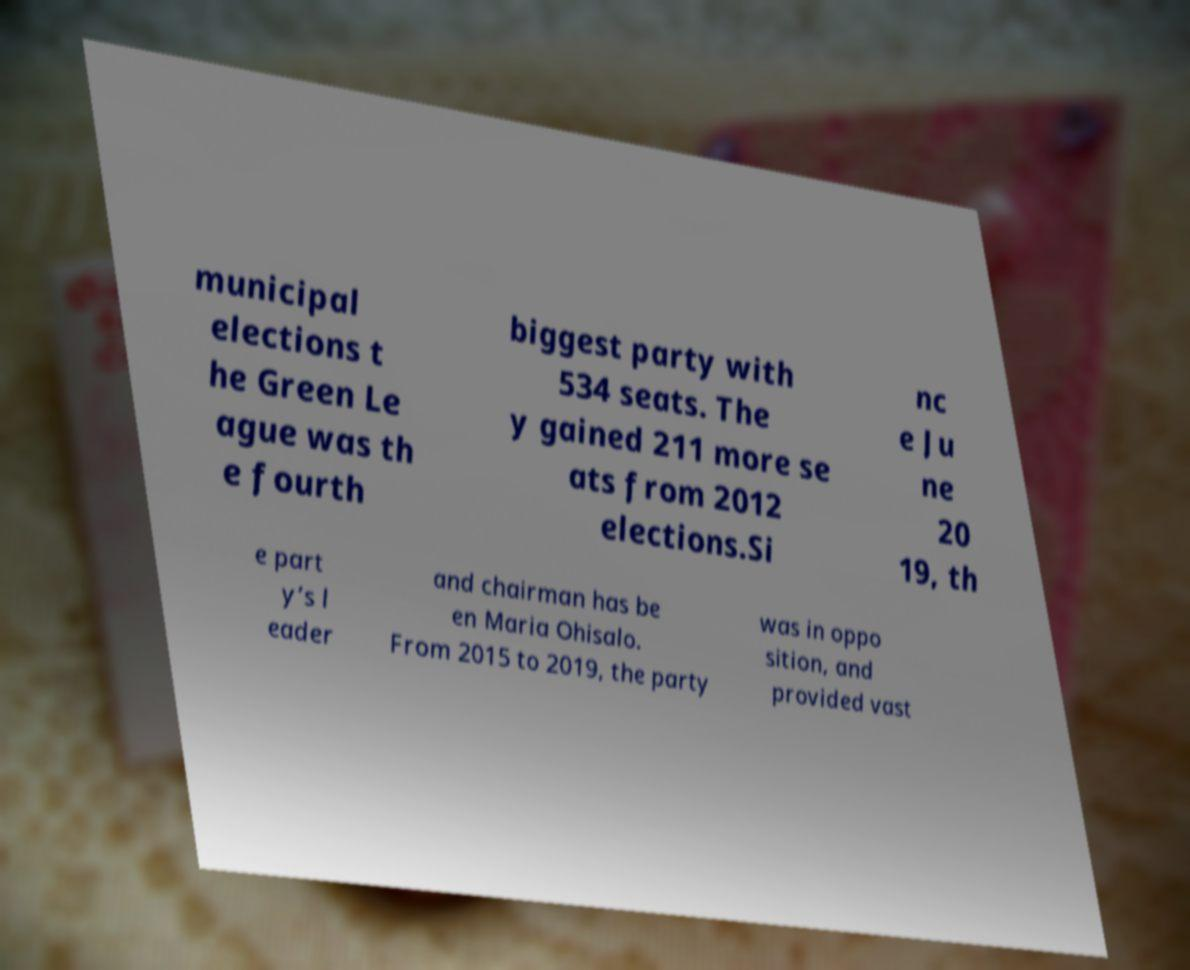What messages or text are displayed in this image? I need them in a readable, typed format. municipal elections t he Green Le ague was th e fourth biggest party with 534 seats. The y gained 211 more se ats from 2012 elections.Si nc e Ju ne 20 19, th e part y’s l eader and chairman has be en Maria Ohisalo. From 2015 to 2019, the party was in oppo sition, and provided vast 